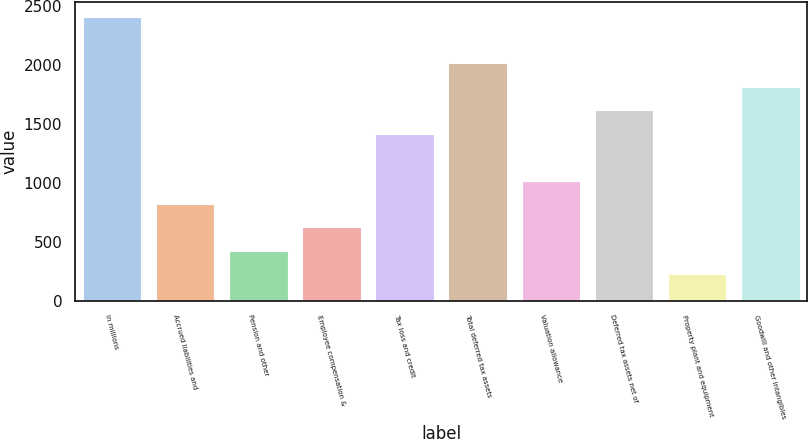Convert chart. <chart><loc_0><loc_0><loc_500><loc_500><bar_chart><fcel>In millions<fcel>Accrued liabilities and<fcel>Pension and other<fcel>Employee compensation &<fcel>Tax loss and credit<fcel>Total deferred tax assets<fcel>Valuation allowance<fcel>Deferred tax assets net of<fcel>Property plant and equipment<fcel>Goodwill and other intangibles<nl><fcel>2410.14<fcel>821.58<fcel>424.44<fcel>623.01<fcel>1417.29<fcel>2013<fcel>1020.15<fcel>1615.86<fcel>225.87<fcel>1814.43<nl></chart> 